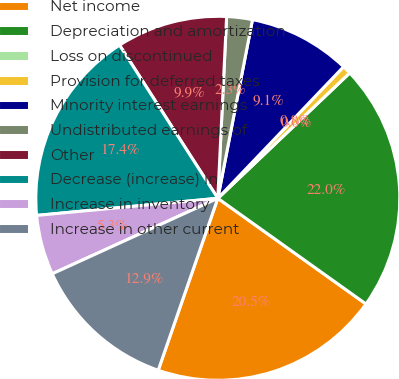<chart> <loc_0><loc_0><loc_500><loc_500><pie_chart><fcel>Net income<fcel>Depreciation and amortization<fcel>Loss on discontinued<fcel>Provision for deferred taxes<fcel>Minority interest earnings<fcel>Undistributed earnings of<fcel>Other<fcel>Decrease (increase) in<fcel>Increase in inventory<fcel>Increase in other current<nl><fcel>20.45%<fcel>21.96%<fcel>0.0%<fcel>0.76%<fcel>9.09%<fcel>2.28%<fcel>9.85%<fcel>17.42%<fcel>5.31%<fcel>12.88%<nl></chart> 